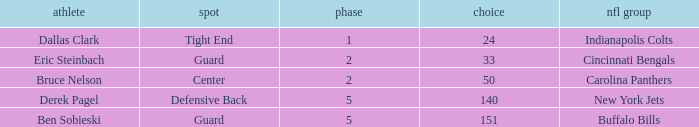What was the latest round that Derek Pagel was selected with a pick higher than 50? 5.0. 